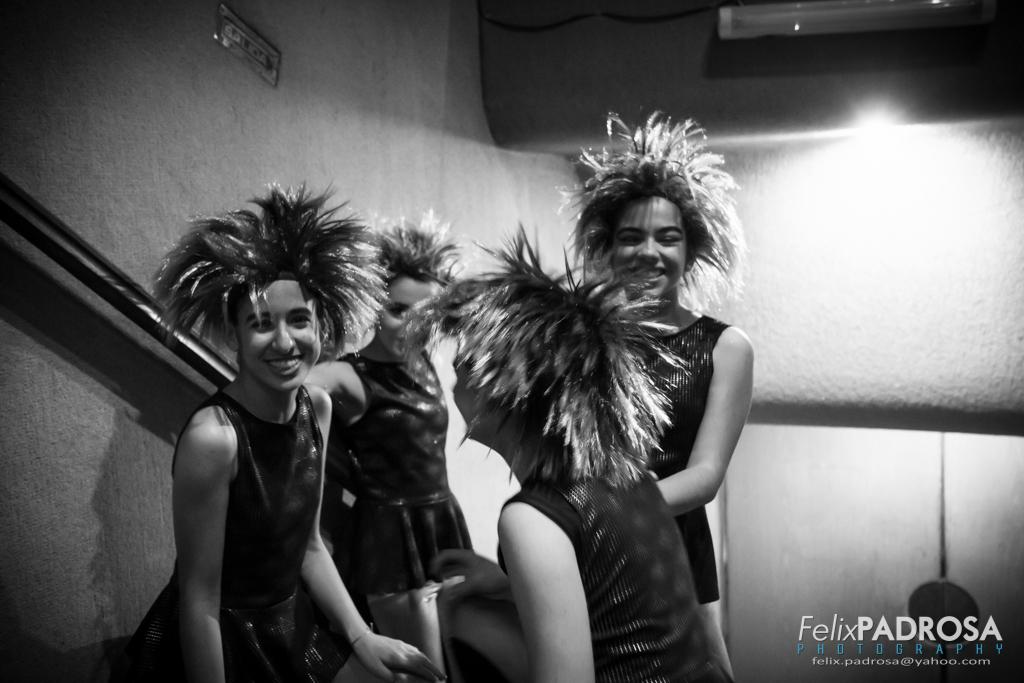What can be seen in the image? There is a group of people in the image. What are the people wearing? The people are wearing dresses and head wears. What is visible in the background of the image? The background of the image includes light. What is the color scheme of the image? The image is black and white. How many rabbits can be seen in the image? There are no rabbits present in the image. In which direction are the people in the image facing? The image does not provide enough information to determine the direction the people are facing. 